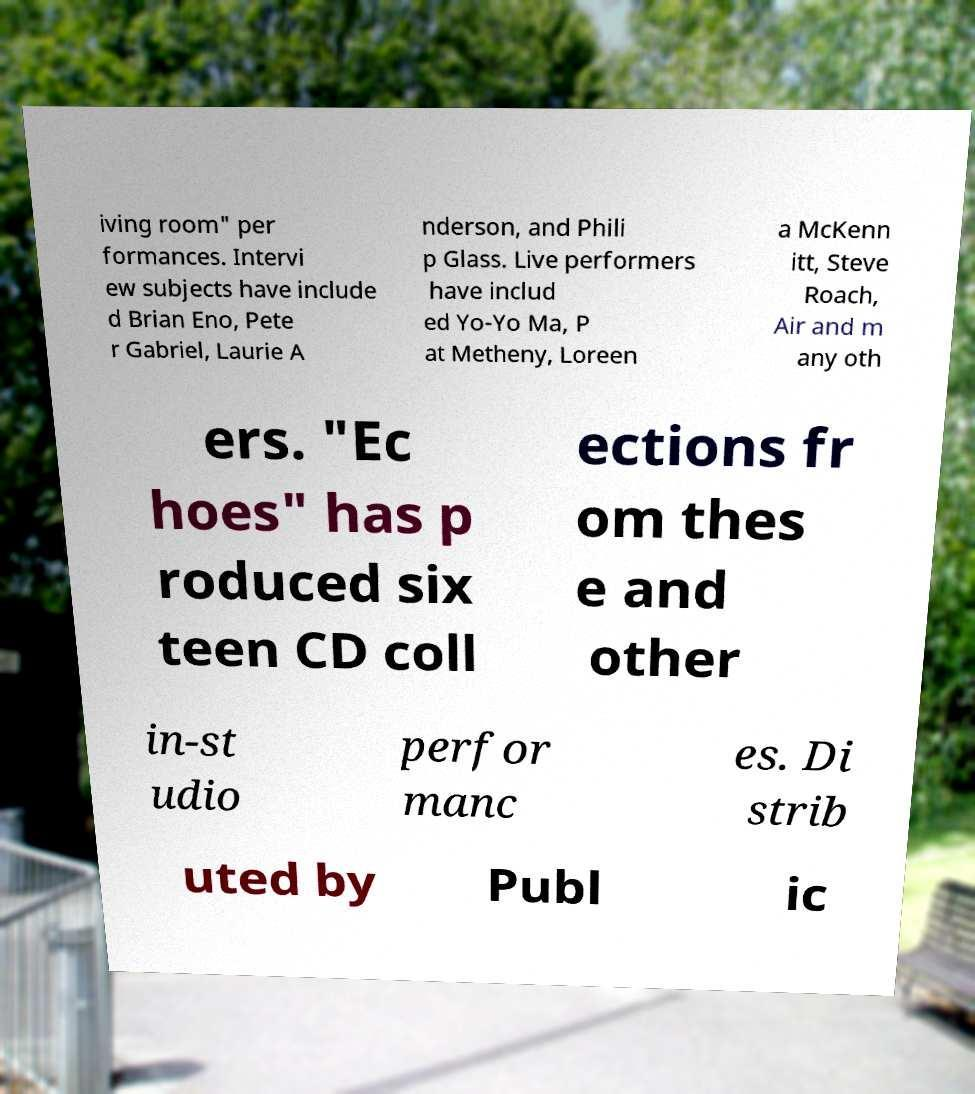There's text embedded in this image that I need extracted. Can you transcribe it verbatim? iving room" per formances. Intervi ew subjects have include d Brian Eno, Pete r Gabriel, Laurie A nderson, and Phili p Glass. Live performers have includ ed Yo-Yo Ma, P at Metheny, Loreen a McKenn itt, Steve Roach, Air and m any oth ers. "Ec hoes" has p roduced six teen CD coll ections fr om thes e and other in-st udio perfor manc es. Di strib uted by Publ ic 